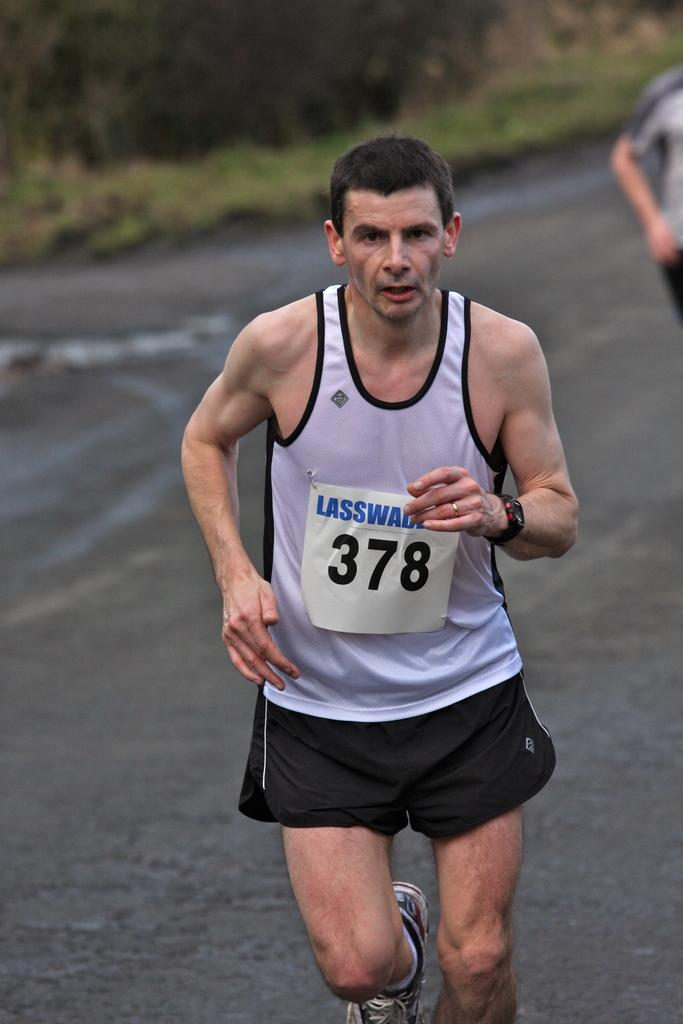<image>
Summarize the visual content of the image. A fatigued looking runner wears a tag with the number 378 on it. 